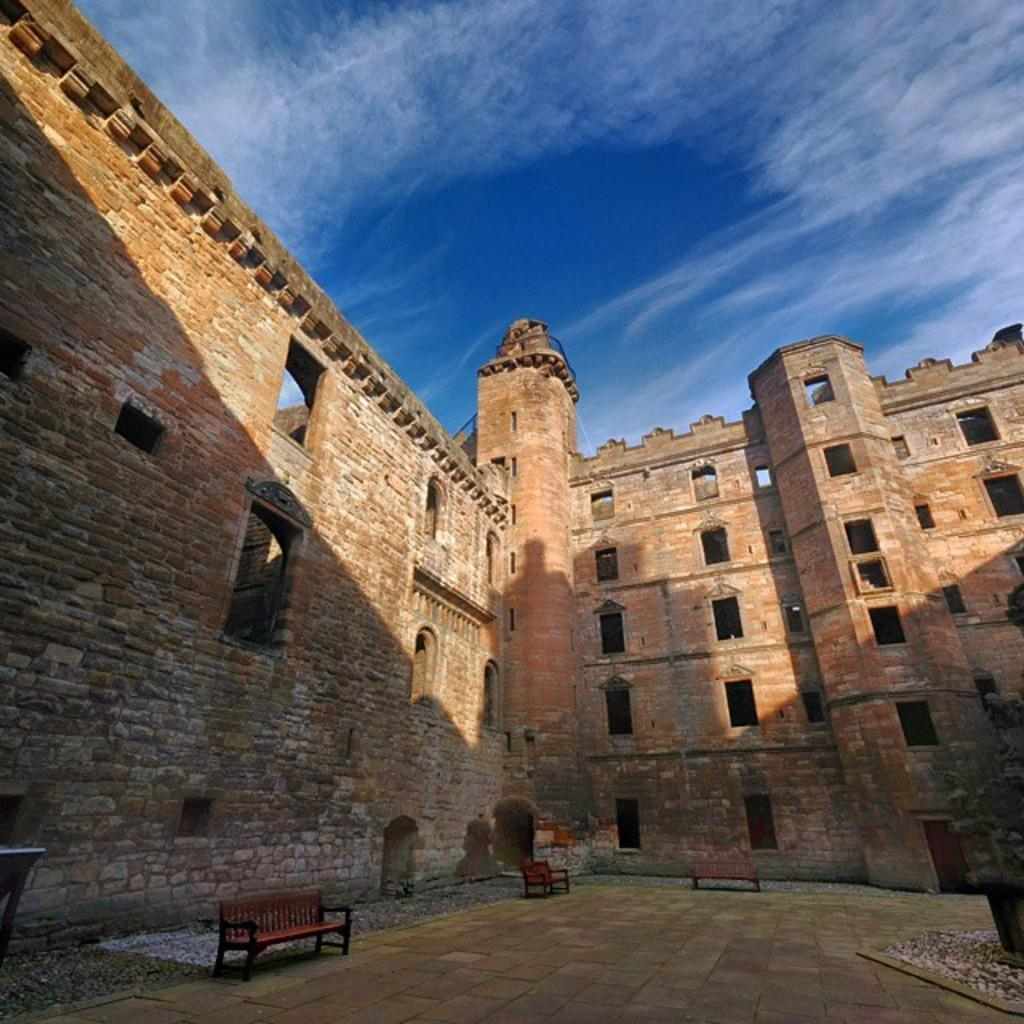What type of structure is visible in the image? There is a building with windows in the image. What can be found near the building? There are benches in the image. What type of material is present on the ground in the image? There are stones in the image. What type of plant is present in the image? There is a plant in a pot on the ground in the image. What is visible in the background of the image? The sky is visible in the image. How would you describe the weather based on the sky in the image? The sky appears cloudy in the image. How many bats are hanging from the building in the image? There are no bats present in the image. 